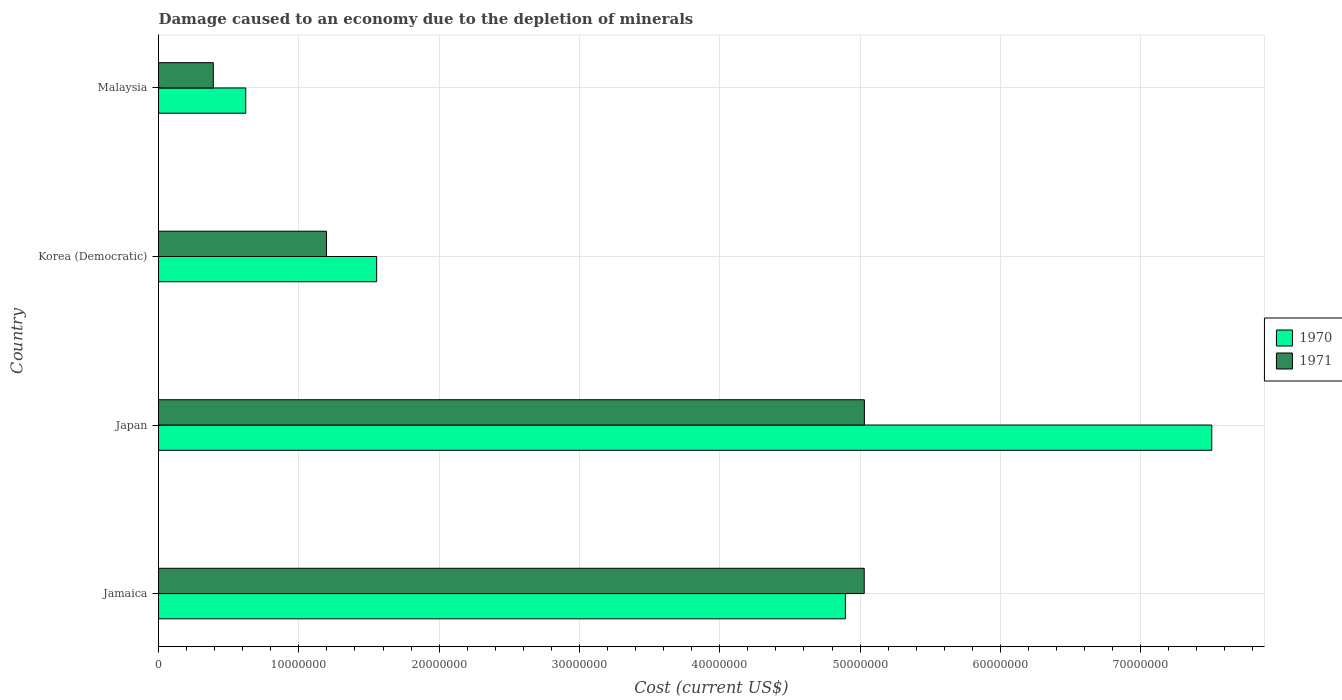How many different coloured bars are there?
Give a very brief answer. 2. Are the number of bars per tick equal to the number of legend labels?
Offer a very short reply. Yes. How many bars are there on the 2nd tick from the top?
Give a very brief answer. 2. What is the label of the 1st group of bars from the top?
Give a very brief answer. Malaysia. In how many cases, is the number of bars for a given country not equal to the number of legend labels?
Provide a short and direct response. 0. What is the cost of damage caused due to the depletion of minerals in 1970 in Japan?
Make the answer very short. 7.51e+07. Across all countries, what is the maximum cost of damage caused due to the depletion of minerals in 1971?
Give a very brief answer. 5.03e+07. Across all countries, what is the minimum cost of damage caused due to the depletion of minerals in 1971?
Provide a short and direct response. 3.90e+06. In which country was the cost of damage caused due to the depletion of minerals in 1971 maximum?
Your response must be concise. Japan. In which country was the cost of damage caused due to the depletion of minerals in 1970 minimum?
Give a very brief answer. Malaysia. What is the total cost of damage caused due to the depletion of minerals in 1970 in the graph?
Provide a succinct answer. 1.46e+08. What is the difference between the cost of damage caused due to the depletion of minerals in 1970 in Jamaica and that in Japan?
Ensure brevity in your answer.  -2.61e+07. What is the difference between the cost of damage caused due to the depletion of minerals in 1971 in Japan and the cost of damage caused due to the depletion of minerals in 1970 in Malaysia?
Make the answer very short. 4.41e+07. What is the average cost of damage caused due to the depletion of minerals in 1971 per country?
Your response must be concise. 2.91e+07. What is the difference between the cost of damage caused due to the depletion of minerals in 1971 and cost of damage caused due to the depletion of minerals in 1970 in Japan?
Your response must be concise. -2.48e+07. In how many countries, is the cost of damage caused due to the depletion of minerals in 1971 greater than 26000000 US$?
Your response must be concise. 2. What is the ratio of the cost of damage caused due to the depletion of minerals in 1970 in Japan to that in Korea (Democratic)?
Provide a short and direct response. 4.83. What is the difference between the highest and the second highest cost of damage caused due to the depletion of minerals in 1970?
Provide a short and direct response. 2.61e+07. What is the difference between the highest and the lowest cost of damage caused due to the depletion of minerals in 1971?
Offer a very short reply. 4.64e+07. Is the sum of the cost of damage caused due to the depletion of minerals in 1971 in Japan and Malaysia greater than the maximum cost of damage caused due to the depletion of minerals in 1970 across all countries?
Ensure brevity in your answer.  No. What does the 1st bar from the top in Japan represents?
Your response must be concise. 1971. How many bars are there?
Your answer should be compact. 8. What is the difference between two consecutive major ticks on the X-axis?
Make the answer very short. 1.00e+07. Are the values on the major ticks of X-axis written in scientific E-notation?
Your answer should be compact. No. Where does the legend appear in the graph?
Offer a terse response. Center right. What is the title of the graph?
Ensure brevity in your answer.  Damage caused to an economy due to the depletion of minerals. Does "2011" appear as one of the legend labels in the graph?
Offer a very short reply. No. What is the label or title of the X-axis?
Offer a terse response. Cost (current US$). What is the Cost (current US$) in 1970 in Jamaica?
Your response must be concise. 4.90e+07. What is the Cost (current US$) in 1971 in Jamaica?
Provide a succinct answer. 5.03e+07. What is the Cost (current US$) of 1970 in Japan?
Keep it short and to the point. 7.51e+07. What is the Cost (current US$) of 1971 in Japan?
Give a very brief answer. 5.03e+07. What is the Cost (current US$) of 1970 in Korea (Democratic)?
Make the answer very short. 1.55e+07. What is the Cost (current US$) in 1971 in Korea (Democratic)?
Keep it short and to the point. 1.20e+07. What is the Cost (current US$) of 1970 in Malaysia?
Provide a short and direct response. 6.22e+06. What is the Cost (current US$) in 1971 in Malaysia?
Offer a terse response. 3.90e+06. Across all countries, what is the maximum Cost (current US$) of 1970?
Offer a terse response. 7.51e+07. Across all countries, what is the maximum Cost (current US$) in 1971?
Provide a succinct answer. 5.03e+07. Across all countries, what is the minimum Cost (current US$) of 1970?
Keep it short and to the point. 6.22e+06. Across all countries, what is the minimum Cost (current US$) in 1971?
Your answer should be very brief. 3.90e+06. What is the total Cost (current US$) of 1970 in the graph?
Make the answer very short. 1.46e+08. What is the total Cost (current US$) in 1971 in the graph?
Make the answer very short. 1.16e+08. What is the difference between the Cost (current US$) of 1970 in Jamaica and that in Japan?
Make the answer very short. -2.61e+07. What is the difference between the Cost (current US$) in 1971 in Jamaica and that in Japan?
Make the answer very short. -1.04e+04. What is the difference between the Cost (current US$) of 1970 in Jamaica and that in Korea (Democratic)?
Provide a succinct answer. 3.34e+07. What is the difference between the Cost (current US$) in 1971 in Jamaica and that in Korea (Democratic)?
Ensure brevity in your answer.  3.83e+07. What is the difference between the Cost (current US$) in 1970 in Jamaica and that in Malaysia?
Give a very brief answer. 4.27e+07. What is the difference between the Cost (current US$) of 1971 in Jamaica and that in Malaysia?
Provide a succinct answer. 4.64e+07. What is the difference between the Cost (current US$) in 1970 in Japan and that in Korea (Democratic)?
Provide a succinct answer. 5.95e+07. What is the difference between the Cost (current US$) in 1971 in Japan and that in Korea (Democratic)?
Your answer should be very brief. 3.83e+07. What is the difference between the Cost (current US$) in 1970 in Japan and that in Malaysia?
Provide a succinct answer. 6.88e+07. What is the difference between the Cost (current US$) of 1971 in Japan and that in Malaysia?
Provide a succinct answer. 4.64e+07. What is the difference between the Cost (current US$) in 1970 in Korea (Democratic) and that in Malaysia?
Provide a short and direct response. 9.33e+06. What is the difference between the Cost (current US$) of 1971 in Korea (Democratic) and that in Malaysia?
Ensure brevity in your answer.  8.06e+06. What is the difference between the Cost (current US$) in 1970 in Jamaica and the Cost (current US$) in 1971 in Japan?
Give a very brief answer. -1.35e+06. What is the difference between the Cost (current US$) of 1970 in Jamaica and the Cost (current US$) of 1971 in Korea (Democratic)?
Keep it short and to the point. 3.70e+07. What is the difference between the Cost (current US$) of 1970 in Jamaica and the Cost (current US$) of 1971 in Malaysia?
Keep it short and to the point. 4.51e+07. What is the difference between the Cost (current US$) of 1970 in Japan and the Cost (current US$) of 1971 in Korea (Democratic)?
Ensure brevity in your answer.  6.31e+07. What is the difference between the Cost (current US$) of 1970 in Japan and the Cost (current US$) of 1971 in Malaysia?
Your response must be concise. 7.12e+07. What is the difference between the Cost (current US$) of 1970 in Korea (Democratic) and the Cost (current US$) of 1971 in Malaysia?
Your answer should be very brief. 1.16e+07. What is the average Cost (current US$) of 1970 per country?
Your answer should be compact. 3.64e+07. What is the average Cost (current US$) in 1971 per country?
Make the answer very short. 2.91e+07. What is the difference between the Cost (current US$) in 1970 and Cost (current US$) in 1971 in Jamaica?
Make the answer very short. -1.34e+06. What is the difference between the Cost (current US$) of 1970 and Cost (current US$) of 1971 in Japan?
Keep it short and to the point. 2.48e+07. What is the difference between the Cost (current US$) of 1970 and Cost (current US$) of 1971 in Korea (Democratic)?
Your response must be concise. 3.58e+06. What is the difference between the Cost (current US$) in 1970 and Cost (current US$) in 1971 in Malaysia?
Offer a very short reply. 2.31e+06. What is the ratio of the Cost (current US$) in 1970 in Jamaica to that in Japan?
Make the answer very short. 0.65. What is the ratio of the Cost (current US$) in 1971 in Jamaica to that in Japan?
Offer a very short reply. 1. What is the ratio of the Cost (current US$) of 1970 in Jamaica to that in Korea (Democratic)?
Give a very brief answer. 3.15. What is the ratio of the Cost (current US$) in 1971 in Jamaica to that in Korea (Democratic)?
Offer a terse response. 4.2. What is the ratio of the Cost (current US$) in 1970 in Jamaica to that in Malaysia?
Your answer should be compact. 7.87. What is the ratio of the Cost (current US$) of 1971 in Jamaica to that in Malaysia?
Keep it short and to the point. 12.88. What is the ratio of the Cost (current US$) in 1970 in Japan to that in Korea (Democratic)?
Ensure brevity in your answer.  4.83. What is the ratio of the Cost (current US$) of 1971 in Japan to that in Korea (Democratic)?
Provide a short and direct response. 4.2. What is the ratio of the Cost (current US$) of 1970 in Japan to that in Malaysia?
Your response must be concise. 12.07. What is the ratio of the Cost (current US$) in 1971 in Japan to that in Malaysia?
Offer a terse response. 12.88. What is the ratio of the Cost (current US$) of 1970 in Korea (Democratic) to that in Malaysia?
Give a very brief answer. 2.5. What is the ratio of the Cost (current US$) in 1971 in Korea (Democratic) to that in Malaysia?
Provide a short and direct response. 3.07. What is the difference between the highest and the second highest Cost (current US$) in 1970?
Give a very brief answer. 2.61e+07. What is the difference between the highest and the second highest Cost (current US$) of 1971?
Give a very brief answer. 1.04e+04. What is the difference between the highest and the lowest Cost (current US$) in 1970?
Offer a very short reply. 6.88e+07. What is the difference between the highest and the lowest Cost (current US$) in 1971?
Keep it short and to the point. 4.64e+07. 